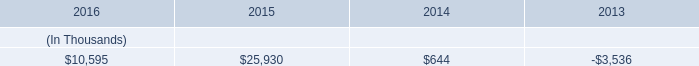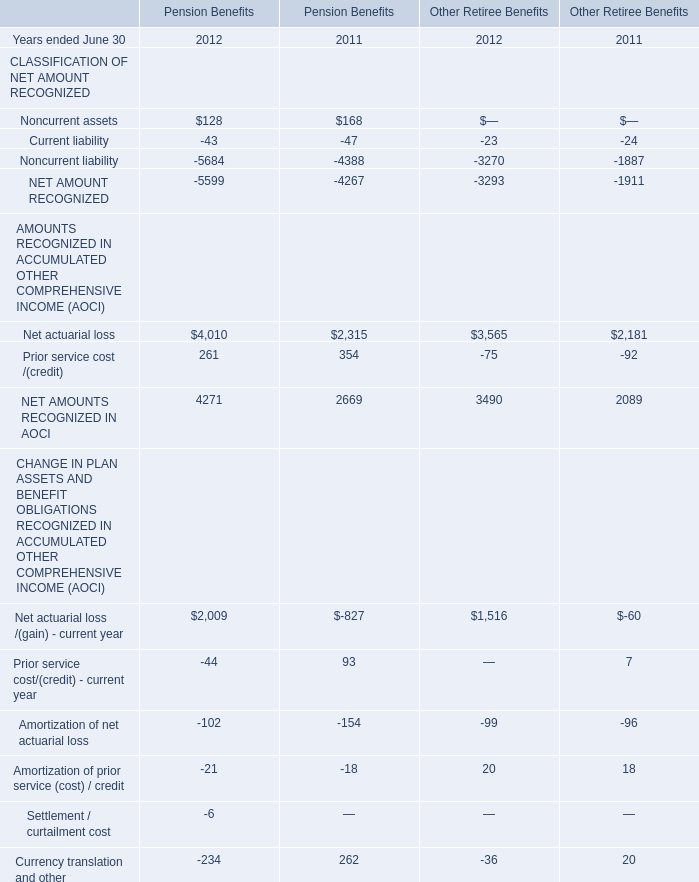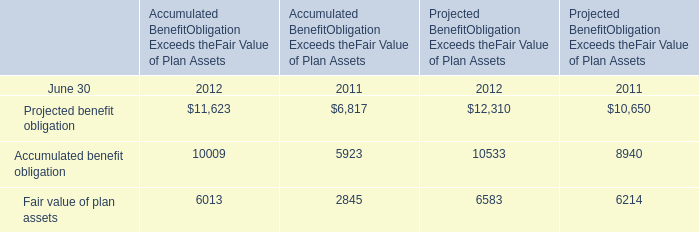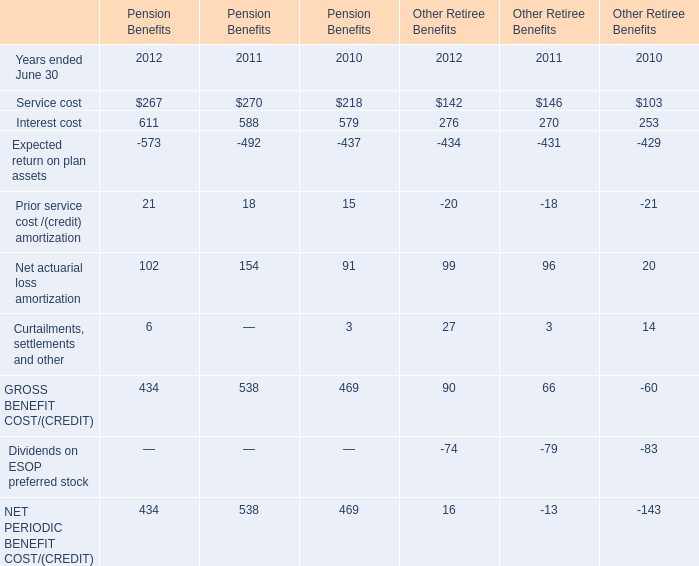In what year is Accumulated benefit obligation for Accumulated Benefit Obligation Exceeds the Fair Value of Plan Assets greater than 10000? 
Answer: 2012. 